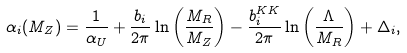<formula> <loc_0><loc_0><loc_500><loc_500>\alpha _ { i } ( M _ { Z } ) = \frac { 1 } { \alpha _ { U } } + \frac { b _ { i } } { 2 \pi } \ln \left ( \frac { M _ { R } } { M _ { Z } } \right ) - \frac { b _ { i } ^ { K K } } { 2 \pi } \ln \left ( \frac { \Lambda } { M _ { R } } \right ) + \Delta _ { i } ,</formula> 